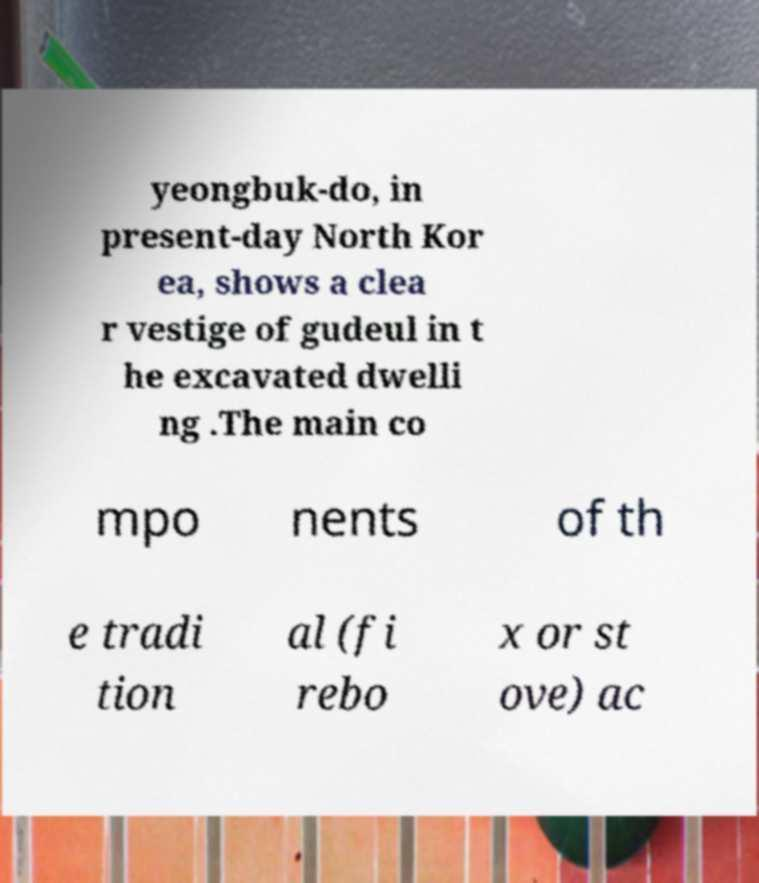There's text embedded in this image that I need extracted. Can you transcribe it verbatim? yeongbuk-do, in present-day North Kor ea, shows a clea r vestige of gudeul in t he excavated dwelli ng .The main co mpo nents of th e tradi tion al (fi rebo x or st ove) ac 